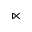<formula> <loc_0><loc_0><loc_500><loc_500>\ltimes</formula> 